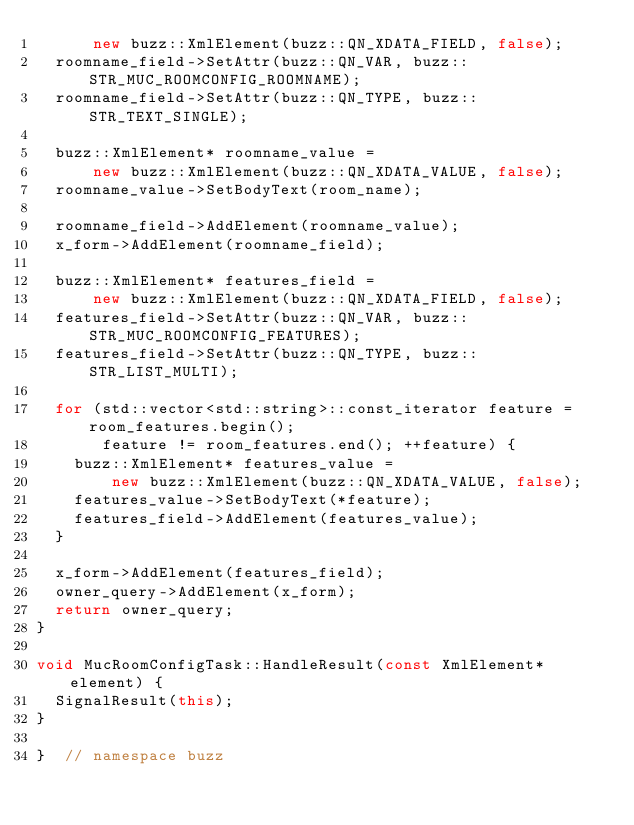<code> <loc_0><loc_0><loc_500><loc_500><_C++_>      new buzz::XmlElement(buzz::QN_XDATA_FIELD, false);
  roomname_field->SetAttr(buzz::QN_VAR, buzz::STR_MUC_ROOMCONFIG_ROOMNAME);
  roomname_field->SetAttr(buzz::QN_TYPE, buzz::STR_TEXT_SINGLE);

  buzz::XmlElement* roomname_value =
      new buzz::XmlElement(buzz::QN_XDATA_VALUE, false);
  roomname_value->SetBodyText(room_name);

  roomname_field->AddElement(roomname_value);
  x_form->AddElement(roomname_field);

  buzz::XmlElement* features_field =
      new buzz::XmlElement(buzz::QN_XDATA_FIELD, false);
  features_field->SetAttr(buzz::QN_VAR, buzz::STR_MUC_ROOMCONFIG_FEATURES);
  features_field->SetAttr(buzz::QN_TYPE, buzz::STR_LIST_MULTI);

  for (std::vector<std::string>::const_iterator feature = room_features.begin();
       feature != room_features.end(); ++feature) {
    buzz::XmlElement* features_value =
        new buzz::XmlElement(buzz::QN_XDATA_VALUE, false);
    features_value->SetBodyText(*feature);
    features_field->AddElement(features_value);
  }

  x_form->AddElement(features_field);
  owner_query->AddElement(x_form);
  return owner_query;
}

void MucRoomConfigTask::HandleResult(const XmlElement* element) {
  SignalResult(this);
}

}  // namespace buzz
</code> 